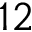Convert formula to latex. <formula><loc_0><loc_0><loc_500><loc_500>1 2</formula> 